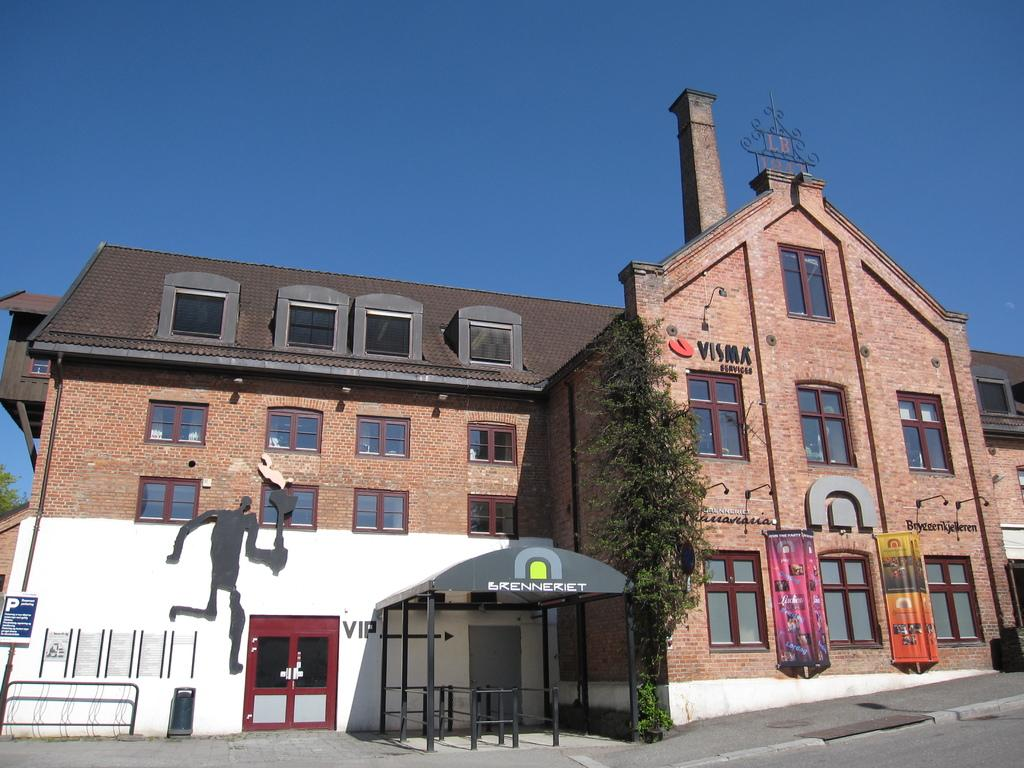What type of structure is present in the image? There is a building in the image. What features can be observed on the building? The building has windows and banners. Are there any natural elements in the image? Yes, there is a tree in the image. What can be seen in the background of the image? The sky is visible in the background of the image. What type of tooth is visible on the building in the image? There is no tooth present on the building in the image. What type of plant is growing on the banners in the image? There are no plants growing on the banners in the image; the banners are attached to the building. 